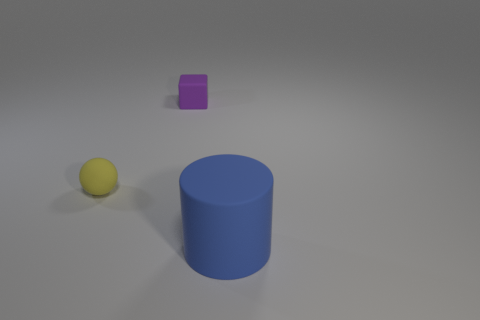Is the color of the tiny object that is on the right side of the yellow ball the same as the rubber cylinder?
Ensure brevity in your answer.  No. What is the material of the tiny thing right of the tiny rubber thing that is left of the tiny object that is behind the yellow rubber sphere?
Keep it short and to the point. Rubber. Are there any other tiny cubes that have the same color as the cube?
Provide a succinct answer. No. Is the number of large matte things that are behind the large blue cylinder less than the number of rubber things?
Offer a very short reply. Yes. Do the object on the left side of the block and the large object have the same size?
Provide a short and direct response. No. What number of objects are both behind the blue object and to the right of the yellow thing?
Provide a succinct answer. 1. There is a rubber object that is in front of the tiny matte thing that is in front of the small purple block; what is its size?
Give a very brief answer. Large. Is the number of large blue things that are behind the tiny purple block less than the number of large rubber cylinders behind the ball?
Provide a succinct answer. No. Is the color of the matte object that is right of the tiny matte block the same as the tiny rubber object in front of the rubber cube?
Ensure brevity in your answer.  No. What material is the object that is on the right side of the yellow matte sphere and in front of the purple matte cube?
Provide a short and direct response. Rubber. 